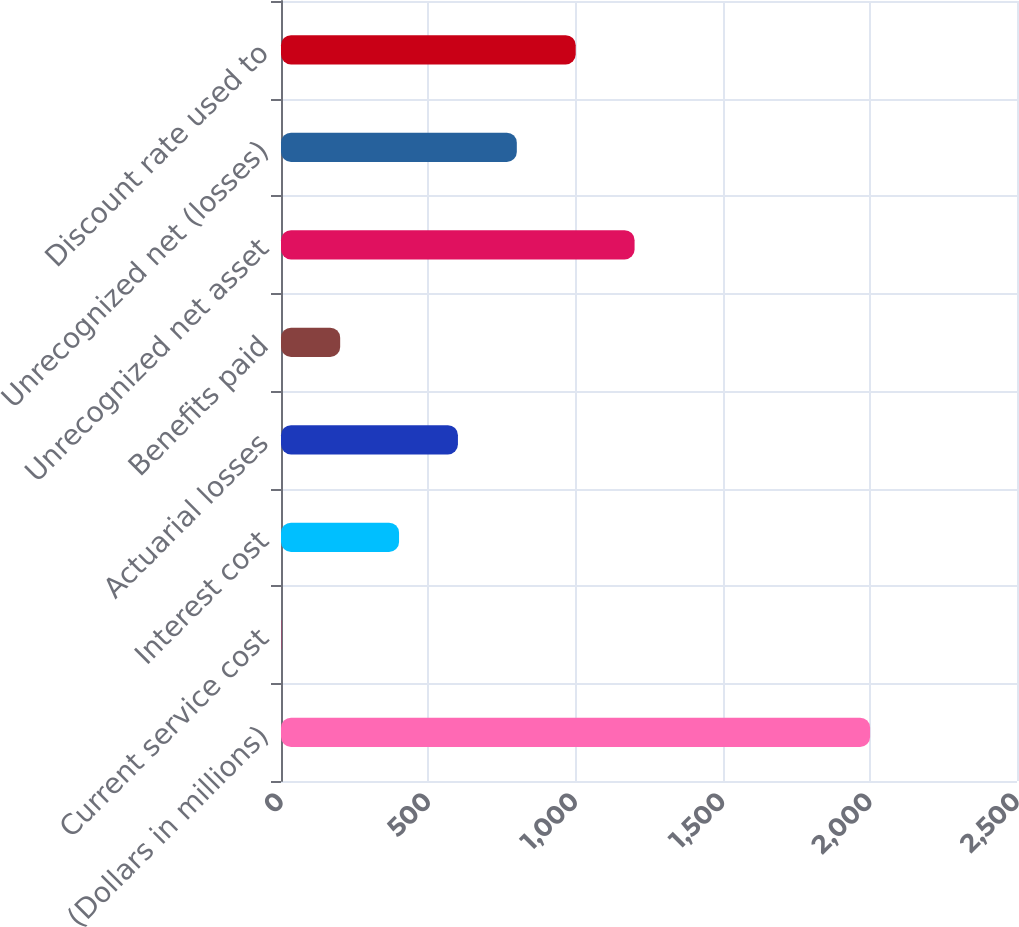<chart> <loc_0><loc_0><loc_500><loc_500><bar_chart><fcel>(Dollars in millions)<fcel>Current service cost<fcel>Interest cost<fcel>Actuarial losses<fcel>Benefits paid<fcel>Unrecognized net asset<fcel>Unrecognized net (losses)<fcel>Discount rate used to<nl><fcel>2001<fcel>1<fcel>401<fcel>601<fcel>201<fcel>1201<fcel>801<fcel>1001<nl></chart> 